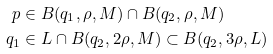<formula> <loc_0><loc_0><loc_500><loc_500>p & \in B ( q _ { 1 } , \rho , M ) \cap B ( q _ { 2 } , \rho , M ) \\ q _ { 1 } & \in L \cap B ( q _ { 2 } , 2 \rho , M ) \subset B ( q _ { 2 } , 3 \rho , L )</formula> 